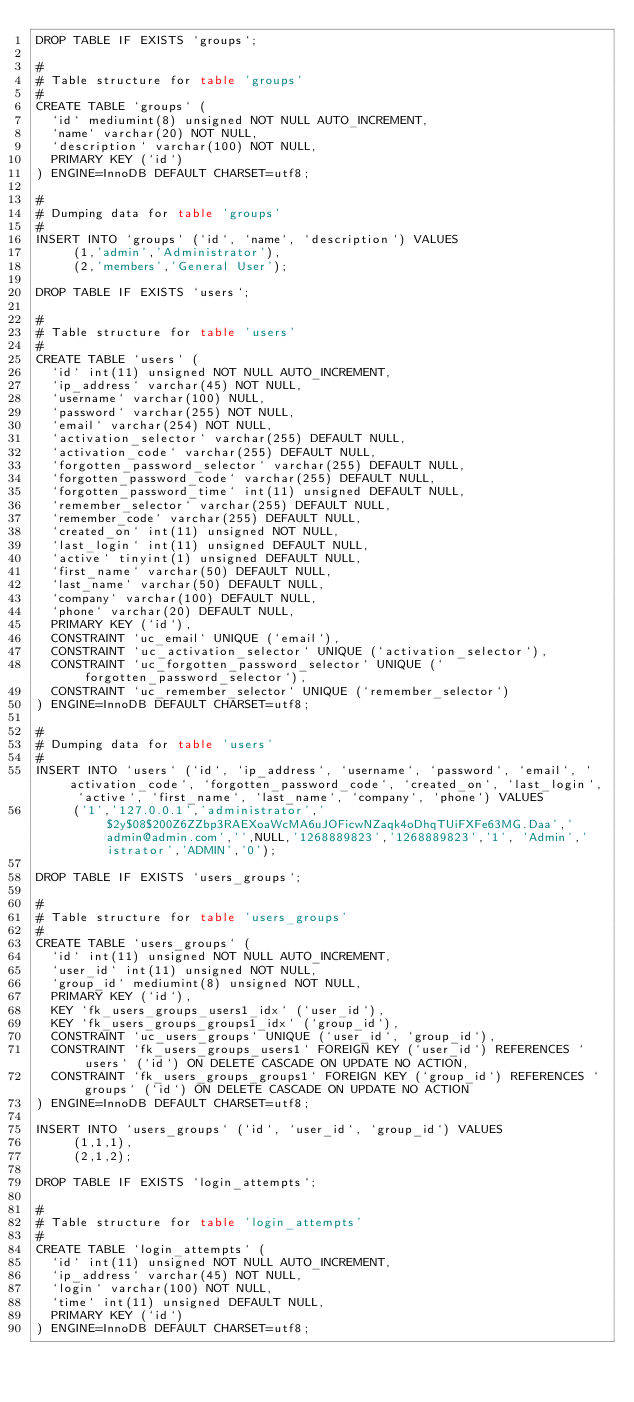Convert code to text. <code><loc_0><loc_0><loc_500><loc_500><_SQL_>DROP TABLE IF EXISTS `groups`;

#
# Table structure for table 'groups'
#
CREATE TABLE `groups` (
  `id` mediumint(8) unsigned NOT NULL AUTO_INCREMENT,
  `name` varchar(20) NOT NULL,
  `description` varchar(100) NOT NULL,
  PRIMARY KEY (`id`)
) ENGINE=InnoDB DEFAULT CHARSET=utf8;

#
# Dumping data for table 'groups'
#
INSERT INTO `groups` (`id`, `name`, `description`) VALUES
     (1,'admin','Administrator'),
     (2,'members','General User');

DROP TABLE IF EXISTS `users`;

#
# Table structure for table 'users'
#
CREATE TABLE `users` (
  `id` int(11) unsigned NOT NULL AUTO_INCREMENT,
  `ip_address` varchar(45) NOT NULL,
  `username` varchar(100) NULL,
  `password` varchar(255) NOT NULL,
  `email` varchar(254) NOT NULL,
  `activation_selector` varchar(255) DEFAULT NULL,
  `activation_code` varchar(255) DEFAULT NULL,
  `forgotten_password_selector` varchar(255) DEFAULT NULL,
  `forgotten_password_code` varchar(255) DEFAULT NULL,
  `forgotten_password_time` int(11) unsigned DEFAULT NULL,
  `remember_selector` varchar(255) DEFAULT NULL,
  `remember_code` varchar(255) DEFAULT NULL,
  `created_on` int(11) unsigned NOT NULL,
  `last_login` int(11) unsigned DEFAULT NULL,
  `active` tinyint(1) unsigned DEFAULT NULL,
  `first_name` varchar(50) DEFAULT NULL,
  `last_name` varchar(50) DEFAULT NULL,
  `company` varchar(100) DEFAULT NULL,
  `phone` varchar(20) DEFAULT NULL,
  PRIMARY KEY (`id`),
  CONSTRAINT `uc_email` UNIQUE (`email`),
  CONSTRAINT `uc_activation_selector` UNIQUE (`activation_selector`),
  CONSTRAINT `uc_forgotten_password_selector` UNIQUE (`forgotten_password_selector`),
  CONSTRAINT `uc_remember_selector` UNIQUE (`remember_selector`)
) ENGINE=InnoDB DEFAULT CHARSET=utf8;

#
# Dumping data for table 'users'
#
INSERT INTO `users` (`id`, `ip_address`, `username`, `password`, `email`, `activation_code`, `forgotten_password_code`, `created_on`, `last_login`, `active`, `first_name`, `last_name`, `company`, `phone`) VALUES
     ('1','127.0.0.1','administrator','$2y$08$200Z6ZZbp3RAEXoaWcMA6uJOFicwNZaqk4oDhqTUiFXFe63MG.Daa','admin@admin.com','',NULL,'1268889823','1268889823','1', 'Admin','istrator','ADMIN','0');

DROP TABLE IF EXISTS `users_groups`;

#
# Table structure for table 'users_groups'
#
CREATE TABLE `users_groups` (
  `id` int(11) unsigned NOT NULL AUTO_INCREMENT,
  `user_id` int(11) unsigned NOT NULL,
  `group_id` mediumint(8) unsigned NOT NULL,
  PRIMARY KEY (`id`),
  KEY `fk_users_groups_users1_idx` (`user_id`),
  KEY `fk_users_groups_groups1_idx` (`group_id`),
  CONSTRAINT `uc_users_groups` UNIQUE (`user_id`, `group_id`),
  CONSTRAINT `fk_users_groups_users1` FOREIGN KEY (`user_id`) REFERENCES `users` (`id`) ON DELETE CASCADE ON UPDATE NO ACTION,
  CONSTRAINT `fk_users_groups_groups1` FOREIGN KEY (`group_id`) REFERENCES `groups` (`id`) ON DELETE CASCADE ON UPDATE NO ACTION
) ENGINE=InnoDB DEFAULT CHARSET=utf8;

INSERT INTO `users_groups` (`id`, `user_id`, `group_id`) VALUES
     (1,1,1),
     (2,1,2);

DROP TABLE IF EXISTS `login_attempts`;

#
# Table structure for table 'login_attempts'
#
CREATE TABLE `login_attempts` (
  `id` int(11) unsigned NOT NULL AUTO_INCREMENT,
  `ip_address` varchar(45) NOT NULL,
  `login` varchar(100) NOT NULL,
  `time` int(11) unsigned DEFAULT NULL,
  PRIMARY KEY (`id`)
) ENGINE=InnoDB DEFAULT CHARSET=utf8;
</code> 